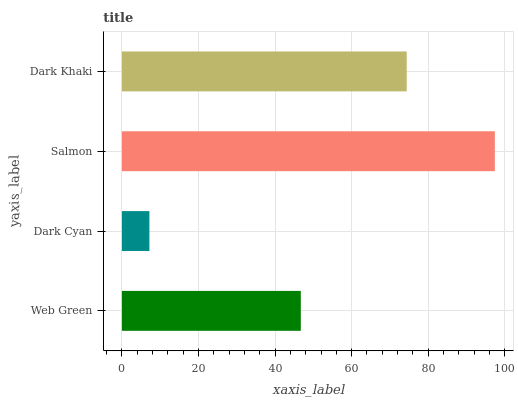Is Dark Cyan the minimum?
Answer yes or no. Yes. Is Salmon the maximum?
Answer yes or no. Yes. Is Salmon the minimum?
Answer yes or no. No. Is Dark Cyan the maximum?
Answer yes or no. No. Is Salmon greater than Dark Cyan?
Answer yes or no. Yes. Is Dark Cyan less than Salmon?
Answer yes or no. Yes. Is Dark Cyan greater than Salmon?
Answer yes or no. No. Is Salmon less than Dark Cyan?
Answer yes or no. No. Is Dark Khaki the high median?
Answer yes or no. Yes. Is Web Green the low median?
Answer yes or no. Yes. Is Dark Cyan the high median?
Answer yes or no. No. Is Salmon the low median?
Answer yes or no. No. 